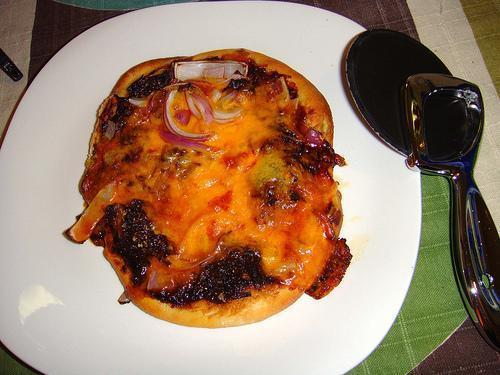How many servings?
Give a very brief answer. 1. 